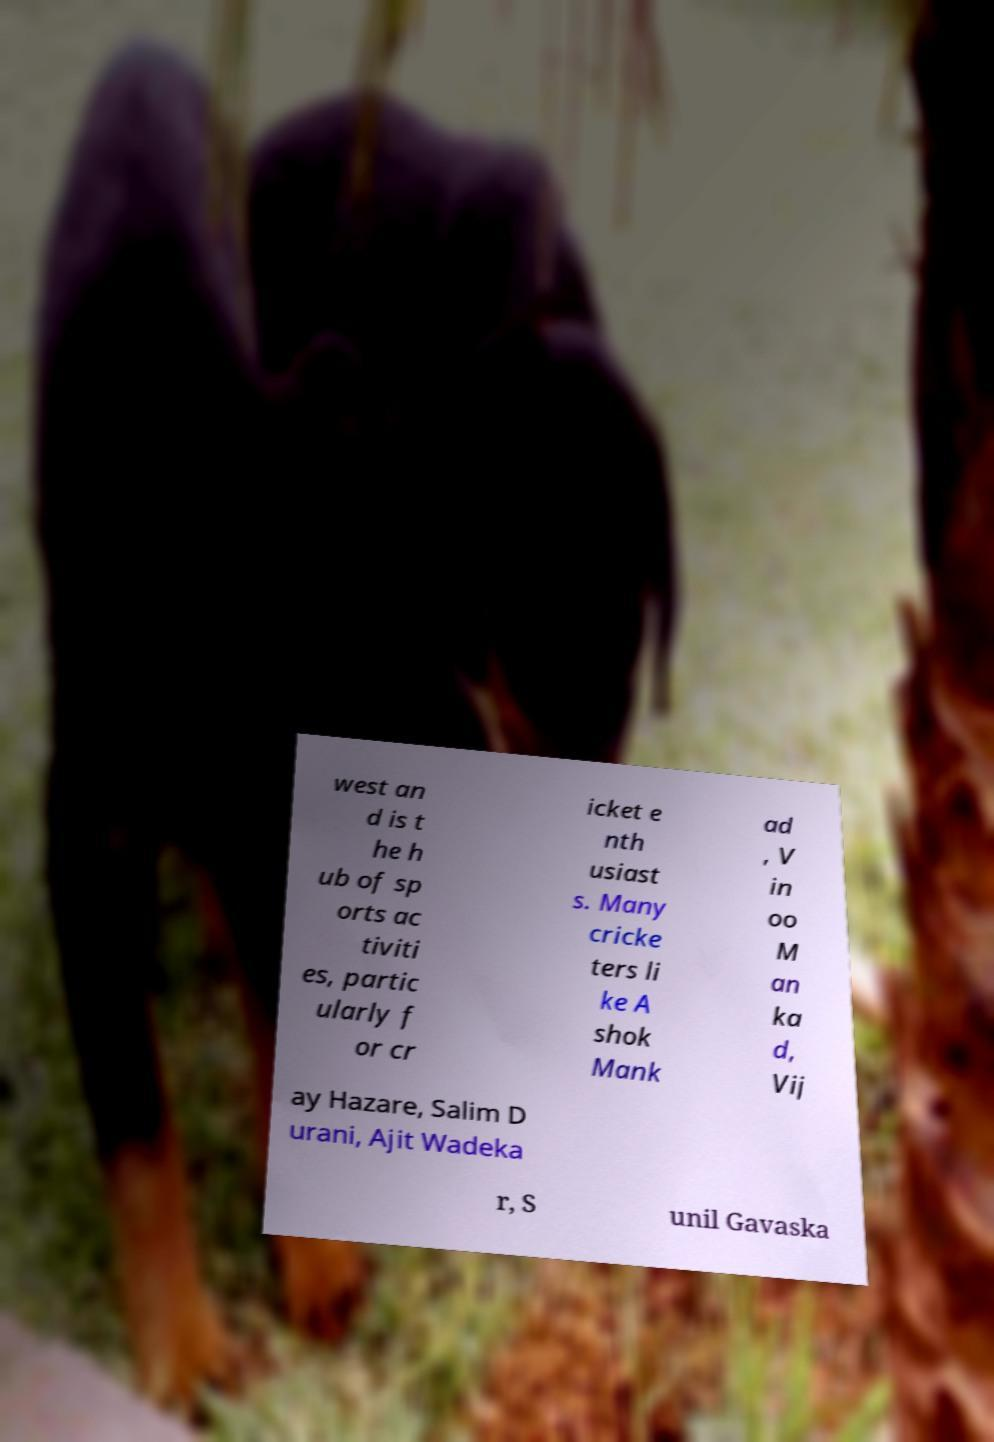I need the written content from this picture converted into text. Can you do that? west an d is t he h ub of sp orts ac tiviti es, partic ularly f or cr icket e nth usiast s. Many cricke ters li ke A shok Mank ad , V in oo M an ka d, Vij ay Hazare, Salim D urani, Ajit Wadeka r, S unil Gavaska 